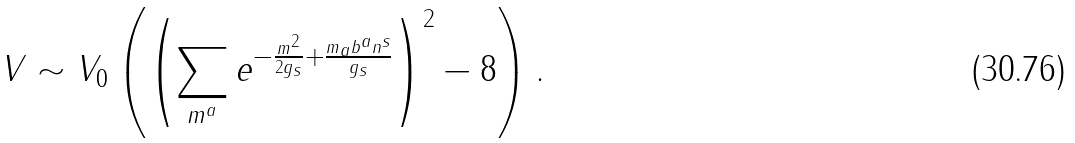Convert formula to latex. <formula><loc_0><loc_0><loc_500><loc_500>V \sim V _ { 0 } \left ( \left ( \sum _ { m ^ { a } } e ^ { - \frac { m ^ { 2 } } { 2 g _ { s } } + \frac { m _ { a } b ^ { a } n ^ { s } } { g _ { s } } } \right ) ^ { 2 } - 8 \right ) .</formula> 